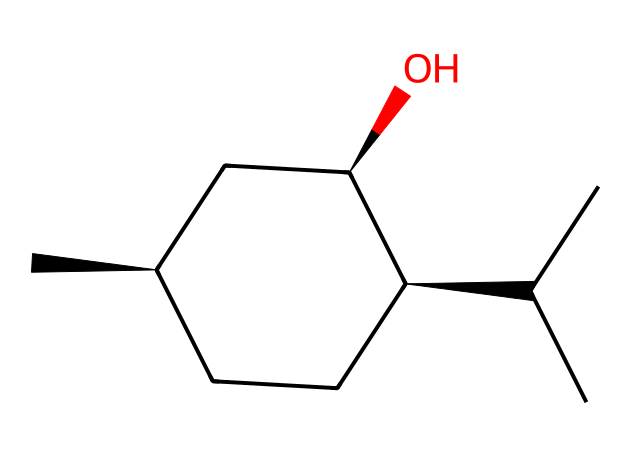What is the molecular formula of menthol? To determine the molecular formula, identify the number of each type of atom in the structure. In this case, there are 10 carbon (C) atoms, 20 hydrogen (H) atoms, and 1 oxygen (O) atom. Therefore, the molecular formula is C10H20O.
Answer: C10H20O How many chiral centers are present in menthol? A chiral center is indicated by a carbon atom that is bonded to four different substituents. By analyzing the structure, we can identify three carbon atoms connected to four distinct groups, indicating three chiral centers.
Answer: 3 What type of isomerism exists in menthol? Menthol can exhibit stereoisomerism due to the presence of chiral centers. The different spatial arrangements of atoms around these centers lead to different stereoisomers, specifically enantiomers.
Answer: stereoisomerism What functional group is present in menthol? The chemical structure of menthol shows a hydroxyl (–OH) group attached to one of the carbon atoms. This characteristic group classifies it as an alcohol.
Answer: alcohol How many rings are in the menthol structure? Inspecting the structure reveals that it contains a single cycloalkane ring, which is part of its saturated hydrocarbon framework. Therefore, the count of ring structures is one.
Answer: 1 What property of menthol contributes to its cooling sensation? The hydroxyl functional group (–OH) and structure of menthol interact with temperature-sensitive nerve endings, which leads to the cooling sensation often described.
Answer: cooling sensation 